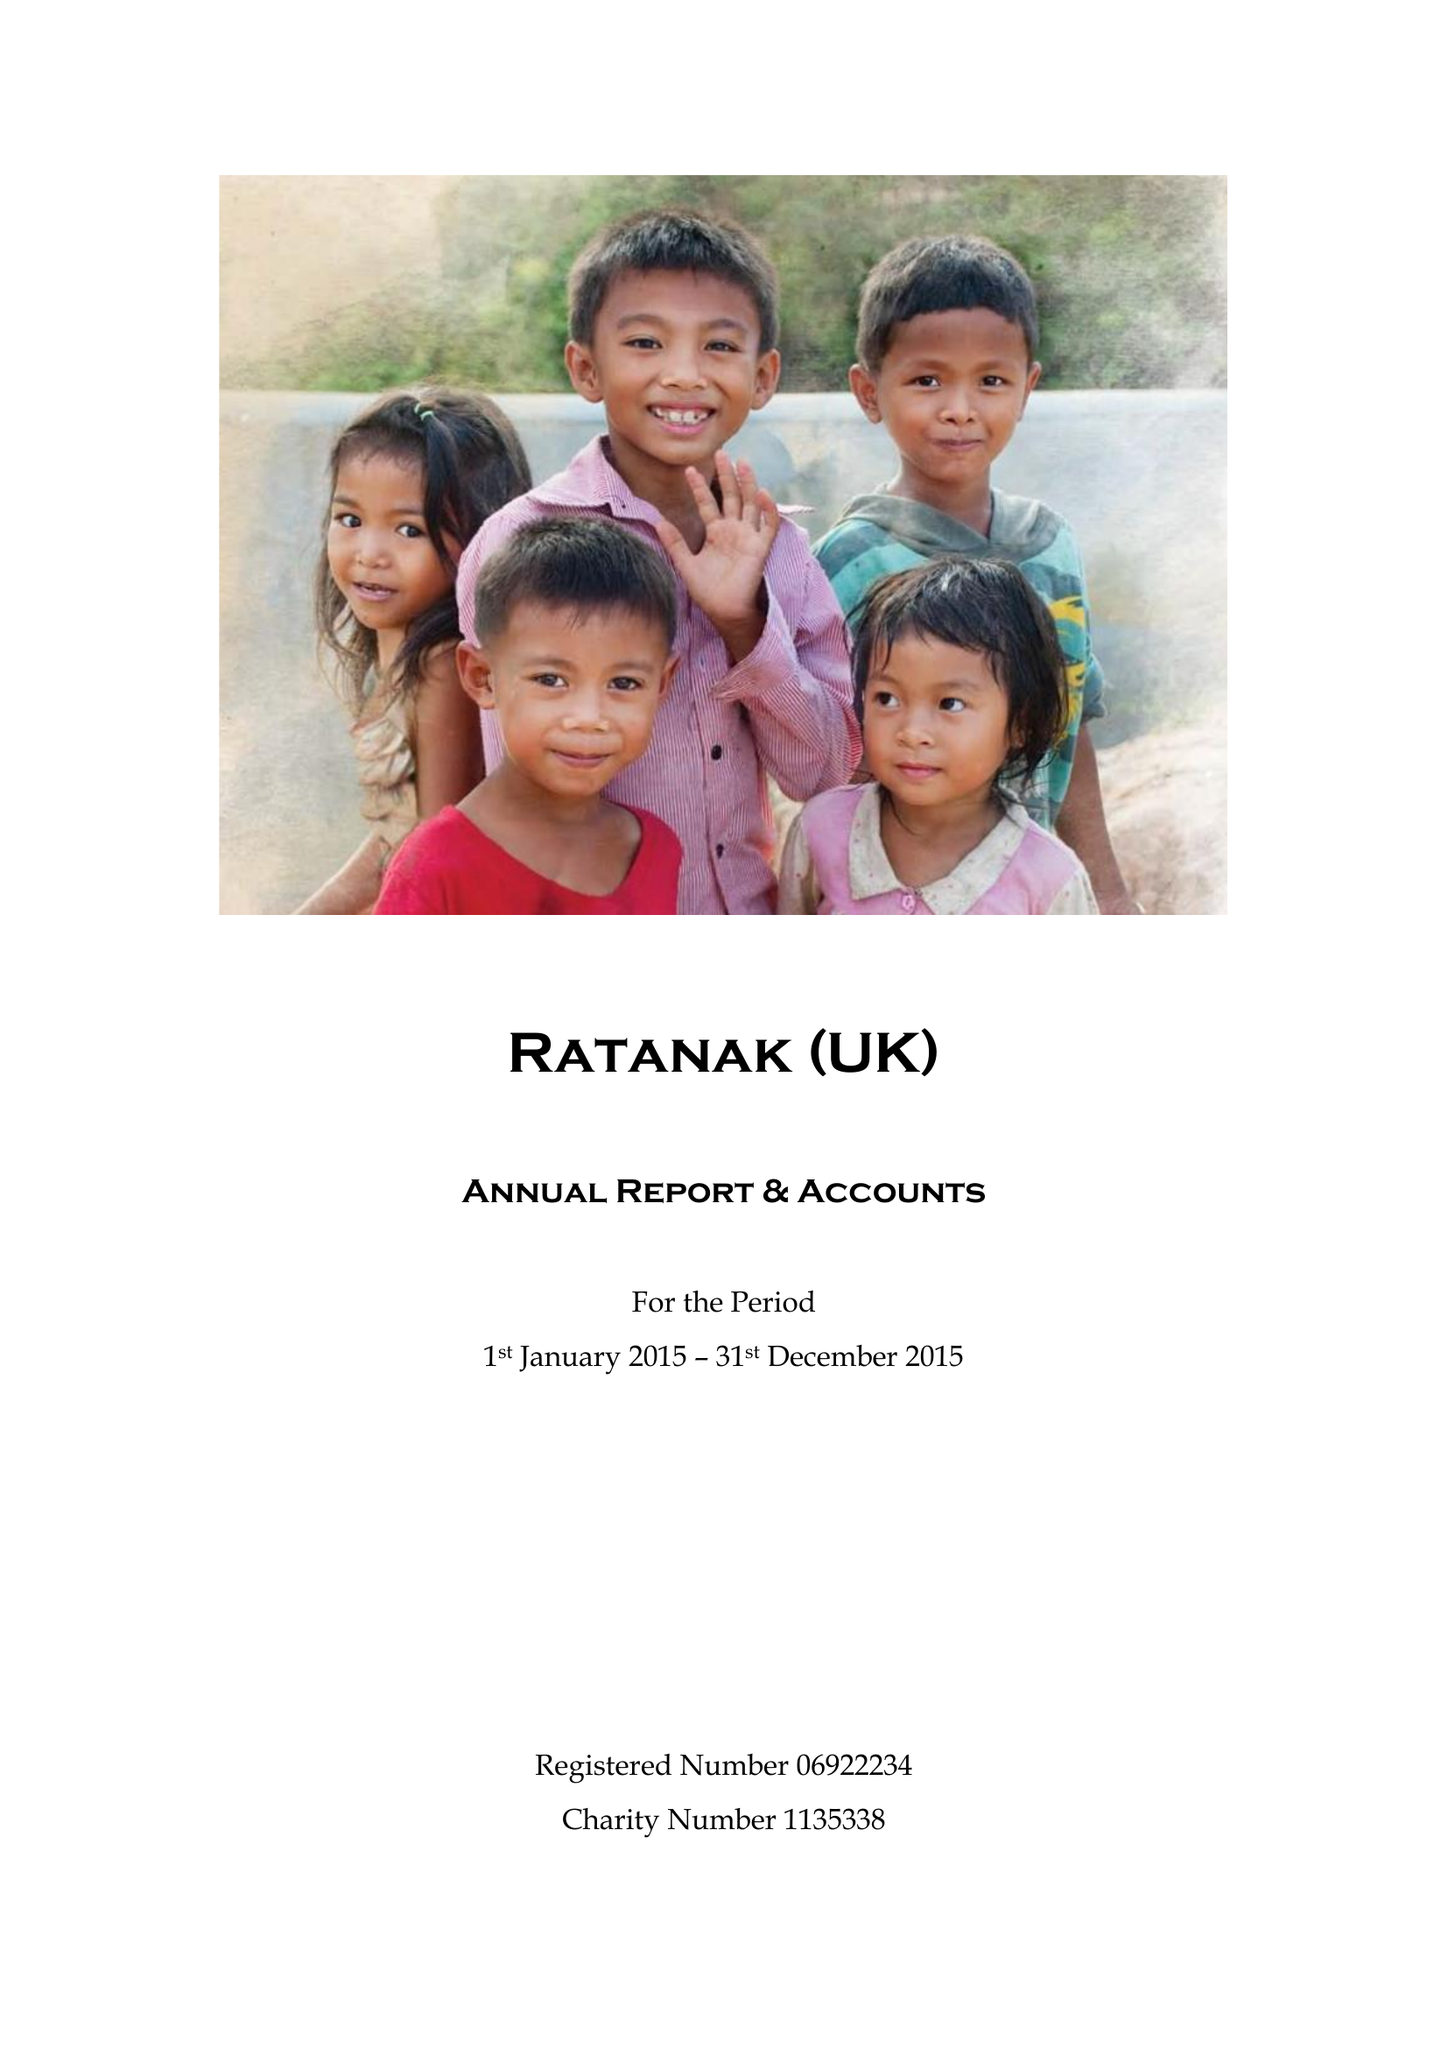What is the value for the income_annually_in_british_pounds?
Answer the question using a single word or phrase. 70702.00 